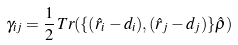<formula> <loc_0><loc_0><loc_500><loc_500>\gamma _ { i j } = \frac { 1 } { 2 } \, T r ( \{ ( \hat { r } _ { i } - d _ { i } ) , ( \hat { r } _ { j } - d _ { j } ) \} \hat { \rho } )</formula> 